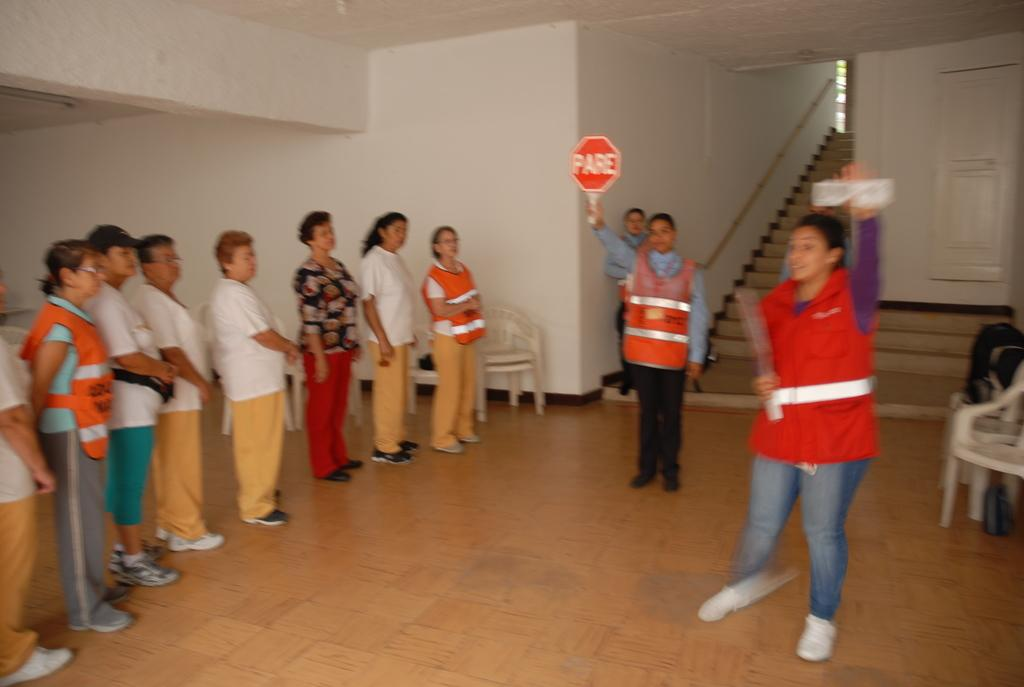<image>
Offer a succinct explanation of the picture presented. A man in an orange vest holds up a sign that says Pare 